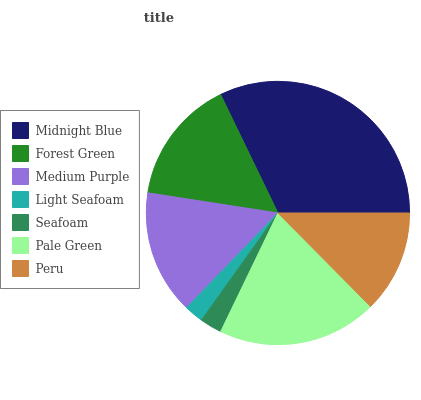Is Light Seafoam the minimum?
Answer yes or no. Yes. Is Midnight Blue the maximum?
Answer yes or no. Yes. Is Forest Green the minimum?
Answer yes or no. No. Is Forest Green the maximum?
Answer yes or no. No. Is Midnight Blue greater than Forest Green?
Answer yes or no. Yes. Is Forest Green less than Midnight Blue?
Answer yes or no. Yes. Is Forest Green greater than Midnight Blue?
Answer yes or no. No. Is Midnight Blue less than Forest Green?
Answer yes or no. No. Is Medium Purple the high median?
Answer yes or no. Yes. Is Medium Purple the low median?
Answer yes or no. Yes. Is Pale Green the high median?
Answer yes or no. No. Is Seafoam the low median?
Answer yes or no. No. 